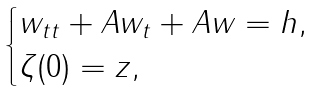Convert formula to latex. <formula><loc_0><loc_0><loc_500><loc_500>\begin{cases} w _ { t t } + A w _ { t } + A w = h , \\ \zeta ( 0 ) = z , \end{cases}</formula> 